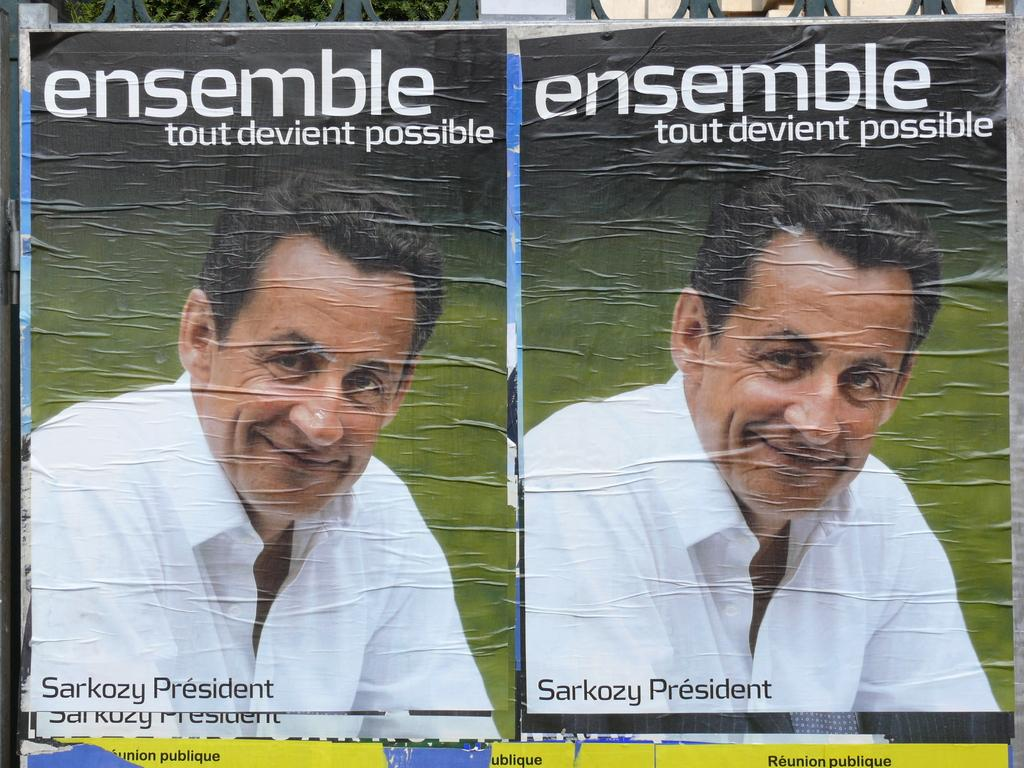What can be seen on the walls in the image? There are posters in the image. What is depicted on the posters? The posters have images of a man. Are there any words on the posters? Yes, there is text on the posters. How many tickets can be seen on the posters in the image? There are no tickets present on the posters in the image. What type of zephyr is blowing through the room in the image? There is no zephyr present in the image; it is a room with posters on the walls. 